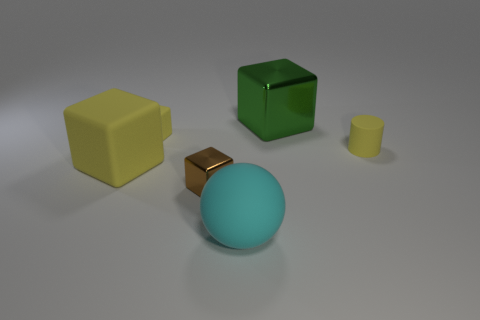How many cylinders are the same size as the brown cube?
Your response must be concise. 1. There is a small brown thing; what number of small matte objects are in front of it?
Keep it short and to the point. 0. There is a large block in front of the metal thing that is behind the tiny brown cube; what is it made of?
Your answer should be compact. Rubber. Are there any other blocks that have the same color as the tiny metallic block?
Make the answer very short. No. What size is the cyan object that is the same material as the large yellow thing?
Make the answer very short. Large. Is there anything else of the same color as the cylinder?
Keep it short and to the point. Yes. What is the color of the tiny cube behind the brown block?
Your answer should be compact. Yellow. There is a metal cube behind the small metallic thing that is on the left side of the large metal block; is there a cyan rubber sphere that is in front of it?
Your answer should be very brief. Yes. Is the number of balls that are behind the matte cylinder greater than the number of large cubes?
Provide a short and direct response. No. There is a small thing on the right side of the tiny metallic object; is it the same shape as the large green object?
Your response must be concise. No. 